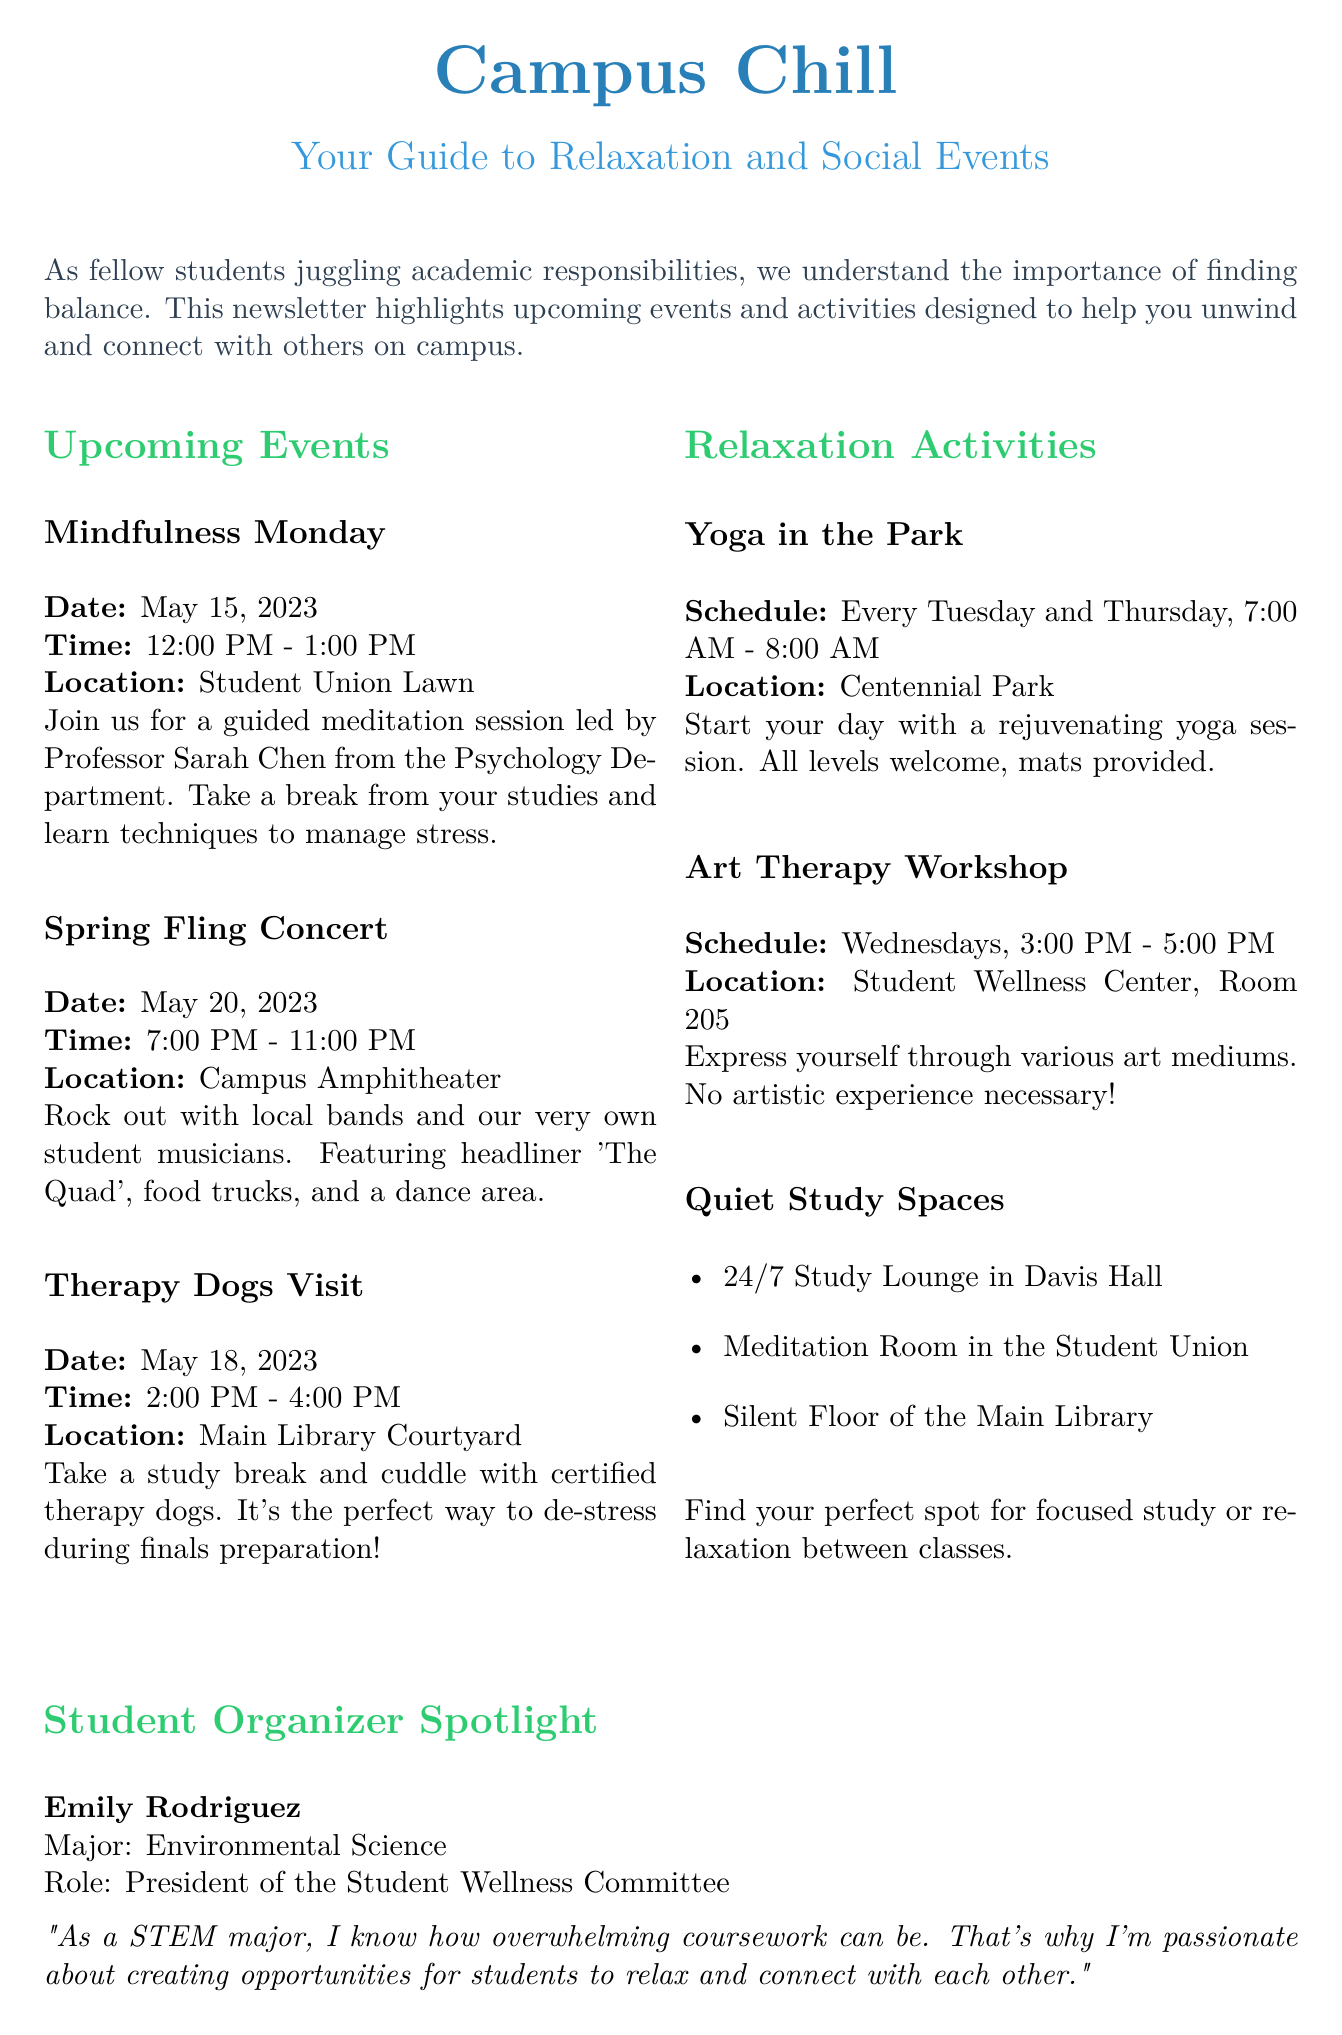What is the title of the newsletter? The title is prominently stated at the beginning of the document.
Answer: Campus Chill When is the Mindfulness Monday event? The document provides the date for this specific event.
Answer: May 15, 2023 Who is leading the meditation session? The document specifies who will lead the Mindfulness Monday event.
Answer: Professor Sarah Chen How long does the Therapy Dogs Visit last? The duration of this event is mentioned in the event details.
Answer: 2 hours What is the location for the Spring Fling Concert? The document clearly states where this event will take place.
Answer: Campus Amphitheater Which major is Emily Rodriguez pursuing? The specific major of the student organizer is mentioned in the spotlight section.
Answer: Environmental Science What is the location of the Art Therapy Workshop? The document states this specific location in the activities section.
Answer: Student Wellness Center, Room 205 What is a self-care tip mentioned in the newsletter? The self-care tip provided encourages a specific behavior.
Answer: Taking breaks How often is Yoga in the Park held? The schedule for this relaxation activity is provided in the document.
Answer: Every Tuesday and Thursday 